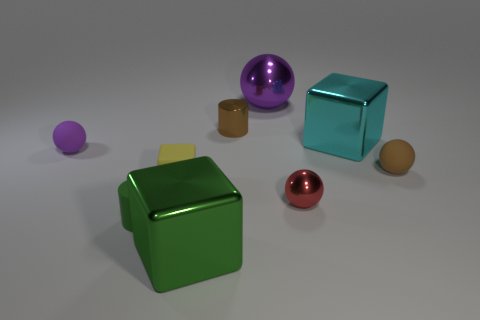Subtract all metallic blocks. How many blocks are left? 1 Subtract all red balls. How many balls are left? 3 Subtract 2 balls. How many balls are left? 2 Subtract all cylinders. How many objects are left? 7 Add 1 small yellow things. How many objects exist? 10 Subtract all gray balls. Subtract all yellow cylinders. How many balls are left? 4 Add 1 small yellow rubber cubes. How many small yellow rubber cubes are left? 2 Add 2 cyan cylinders. How many cyan cylinders exist? 2 Subtract 0 cyan spheres. How many objects are left? 9 Subtract all tiny purple metal cylinders. Subtract all rubber balls. How many objects are left? 7 